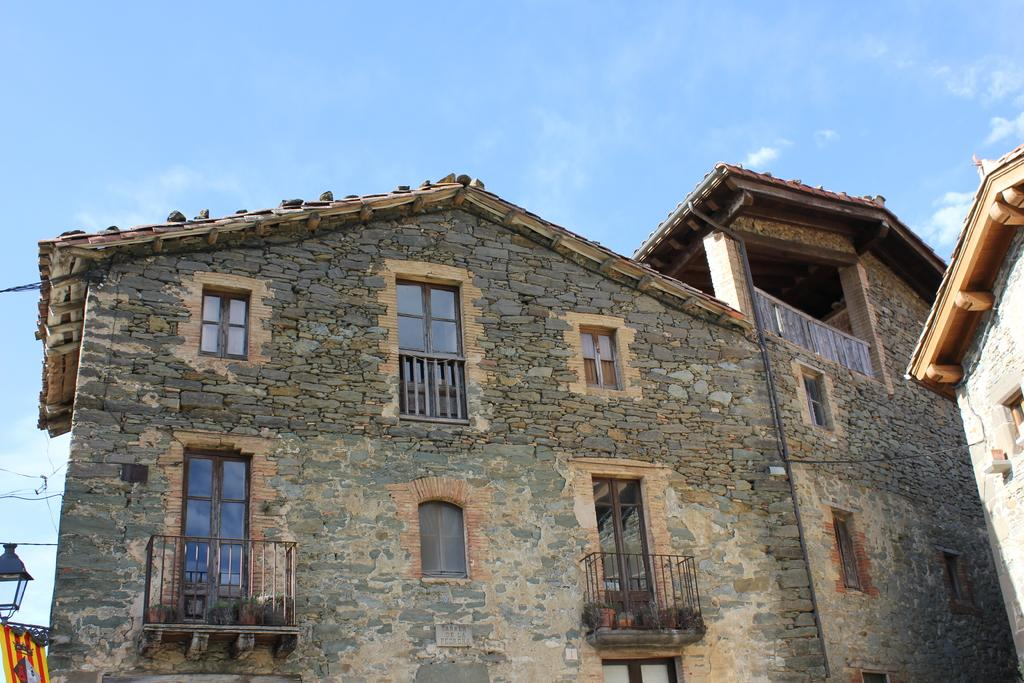What is the main structure in the center of the image? There is a building in the center of the image. What can be seen on the left side of the image? There is a railing on the left side of the image. What is visible at the top of the image? The sky is visible at the top of the image. Is there a pipe leaking water in the image? There is no pipe or indication of water leakage present in the image. 